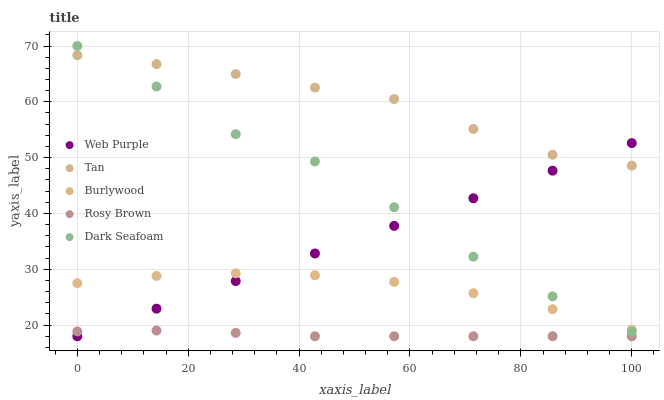Does Rosy Brown have the minimum area under the curve?
Answer yes or no. Yes. Does Tan have the maximum area under the curve?
Answer yes or no. Yes. Does Web Purple have the minimum area under the curve?
Answer yes or no. No. Does Web Purple have the maximum area under the curve?
Answer yes or no. No. Is Web Purple the smoothest?
Answer yes or no. Yes. Is Dark Seafoam the roughest?
Answer yes or no. Yes. Is Rosy Brown the smoothest?
Answer yes or no. No. Is Rosy Brown the roughest?
Answer yes or no. No. Does Web Purple have the lowest value?
Answer yes or no. Yes. Does Tan have the lowest value?
Answer yes or no. No. Does Dark Seafoam have the highest value?
Answer yes or no. Yes. Does Web Purple have the highest value?
Answer yes or no. No. Is Rosy Brown less than Dark Seafoam?
Answer yes or no. Yes. Is Tan greater than Burlywood?
Answer yes or no. Yes. Does Web Purple intersect Tan?
Answer yes or no. Yes. Is Web Purple less than Tan?
Answer yes or no. No. Is Web Purple greater than Tan?
Answer yes or no. No. Does Rosy Brown intersect Dark Seafoam?
Answer yes or no. No. 